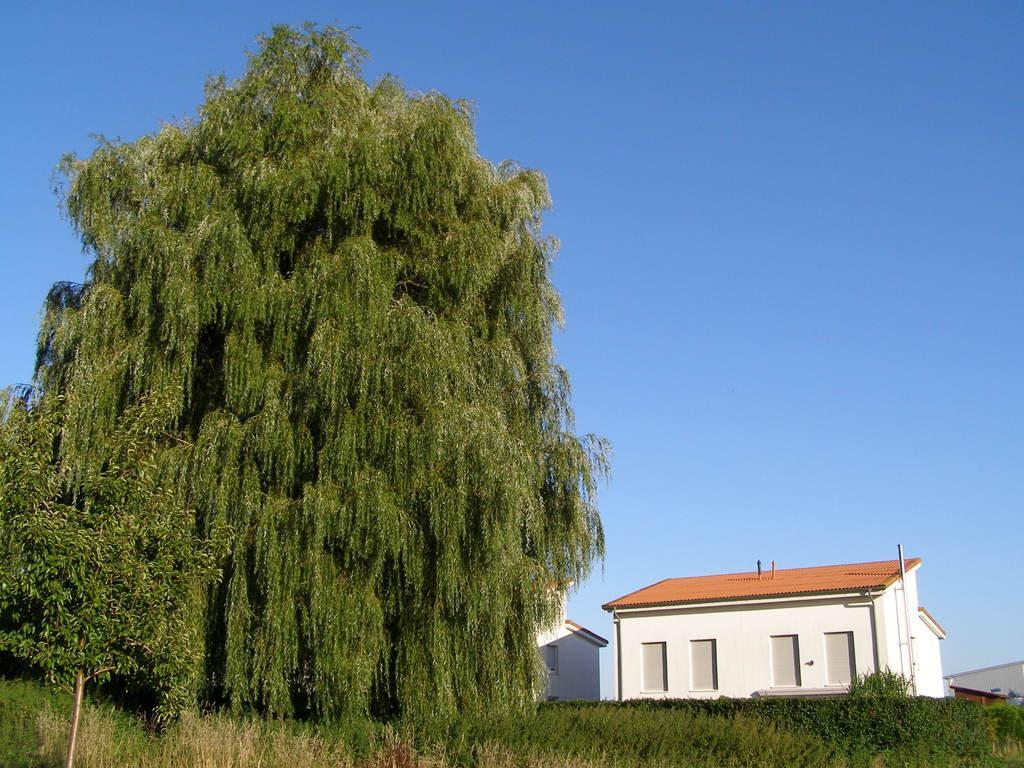Describe this image in one or two sentences. In this image I can see the trees in green color, background I can see few buildings in white color and the sky is in blue color. 